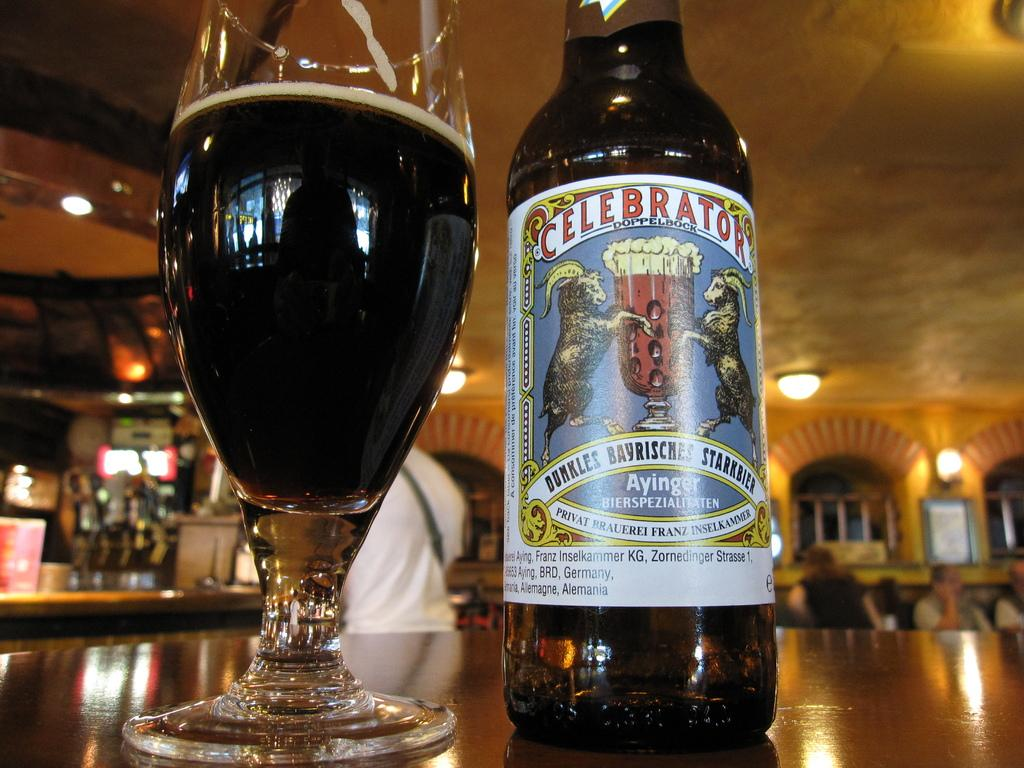<image>
Share a concise interpretation of the image provided. Glass cup and dark brown bottle of Celebrotor 